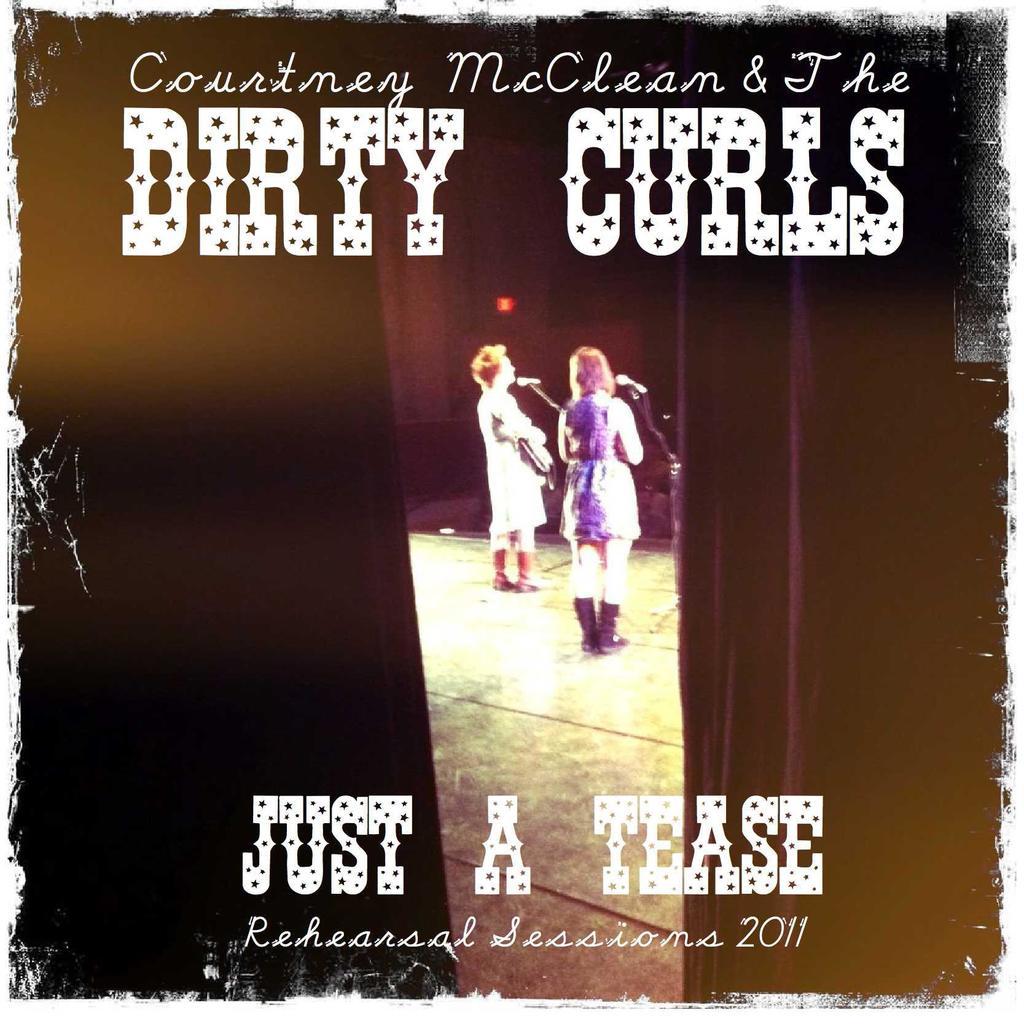What band is this record from?
Offer a terse response. Courtney mcclean & the dirty curls. When was this originally recorded?
Give a very brief answer. 2011. 